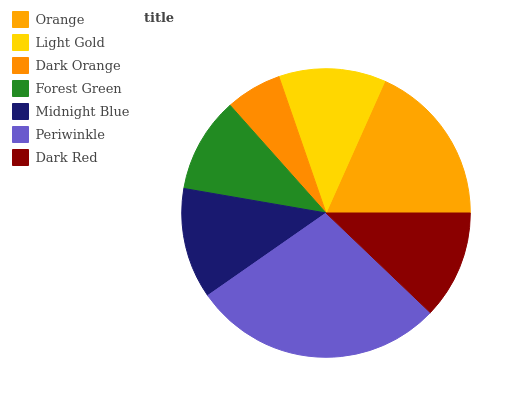Is Dark Orange the minimum?
Answer yes or no. Yes. Is Periwinkle the maximum?
Answer yes or no. Yes. Is Light Gold the minimum?
Answer yes or no. No. Is Light Gold the maximum?
Answer yes or no. No. Is Orange greater than Light Gold?
Answer yes or no. Yes. Is Light Gold less than Orange?
Answer yes or no. Yes. Is Light Gold greater than Orange?
Answer yes or no. No. Is Orange less than Light Gold?
Answer yes or no. No. Is Dark Red the high median?
Answer yes or no. Yes. Is Dark Red the low median?
Answer yes or no. Yes. Is Orange the high median?
Answer yes or no. No. Is Orange the low median?
Answer yes or no. No. 